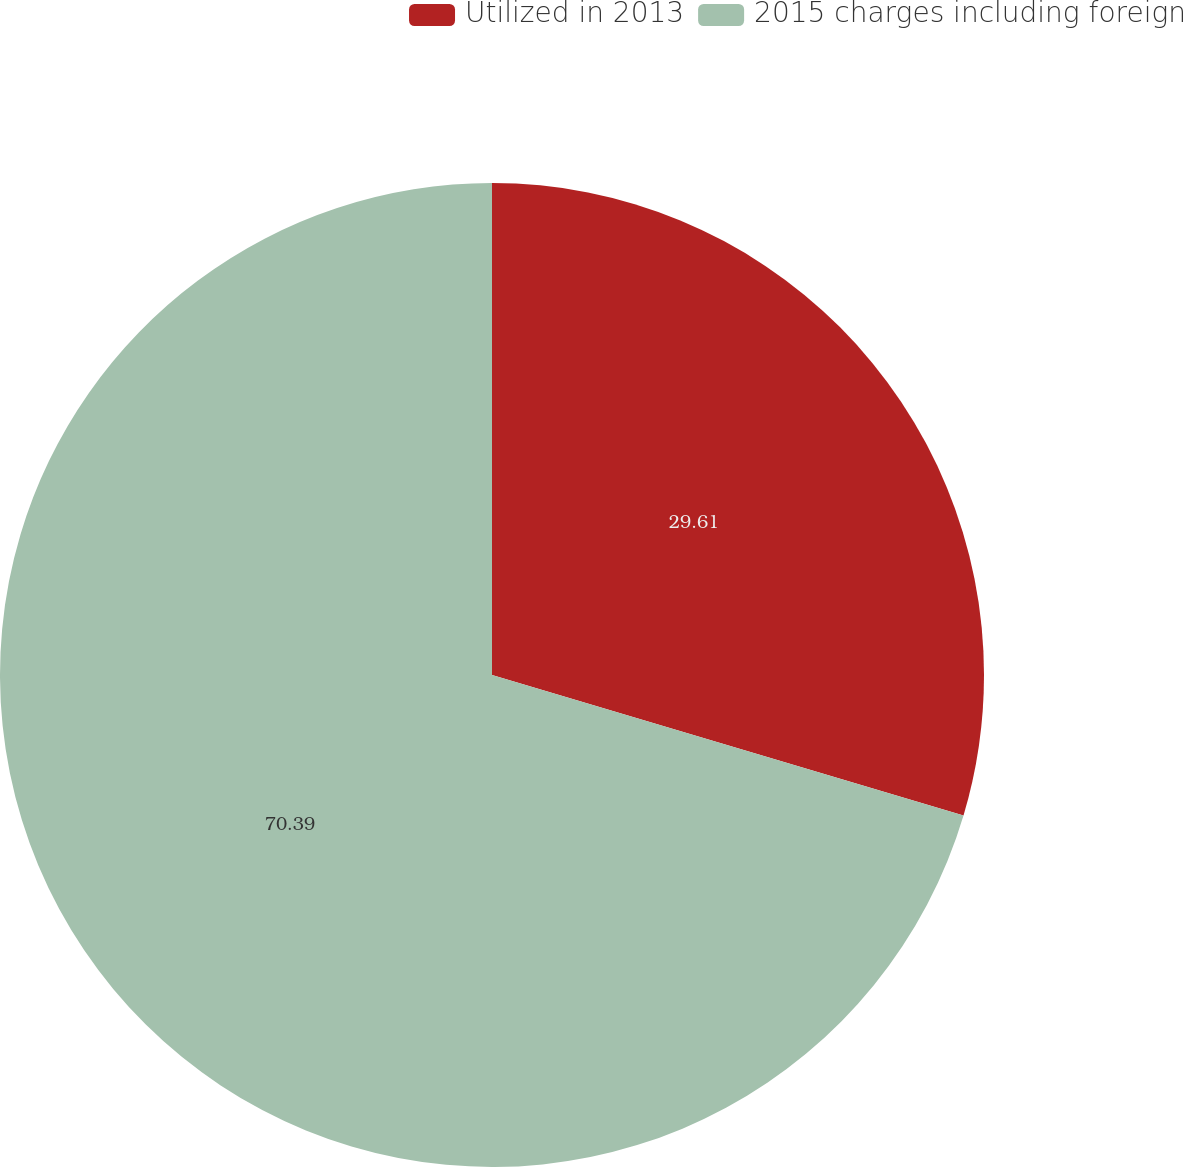<chart> <loc_0><loc_0><loc_500><loc_500><pie_chart><fcel>Utilized in 2013<fcel>2015 charges including foreign<nl><fcel>29.61%<fcel>70.39%<nl></chart> 